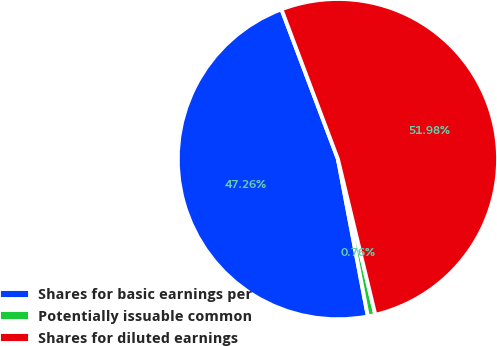Convert chart to OTSL. <chart><loc_0><loc_0><loc_500><loc_500><pie_chart><fcel>Shares for basic earnings per<fcel>Potentially issuable common<fcel>Shares for diluted earnings<nl><fcel>47.26%<fcel>0.76%<fcel>51.98%<nl></chart> 